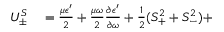<formula> <loc_0><loc_0><loc_500><loc_500>\begin{array} { r l } { U _ { \pm } ^ { S } } & = \frac { \mu \epsilon ^ { \prime } } { 2 } + \frac { \mu \omega } { 2 } \frac { \partial \epsilon ^ { \prime } } { \partial \omega } + \frac { 1 } { 2 } ( S _ { + } ^ { 2 } + S _ { - } ^ { 2 } ) + } \end{array}</formula> 